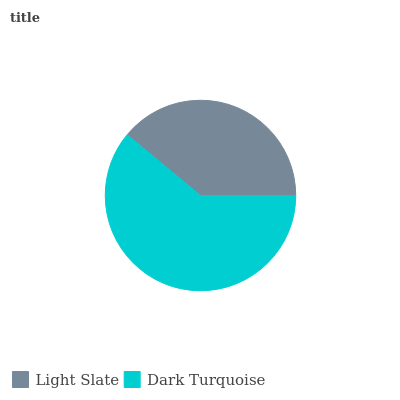Is Light Slate the minimum?
Answer yes or no. Yes. Is Dark Turquoise the maximum?
Answer yes or no. Yes. Is Dark Turquoise the minimum?
Answer yes or no. No. Is Dark Turquoise greater than Light Slate?
Answer yes or no. Yes. Is Light Slate less than Dark Turquoise?
Answer yes or no. Yes. Is Light Slate greater than Dark Turquoise?
Answer yes or no. No. Is Dark Turquoise less than Light Slate?
Answer yes or no. No. Is Dark Turquoise the high median?
Answer yes or no. Yes. Is Light Slate the low median?
Answer yes or no. Yes. Is Light Slate the high median?
Answer yes or no. No. Is Dark Turquoise the low median?
Answer yes or no. No. 